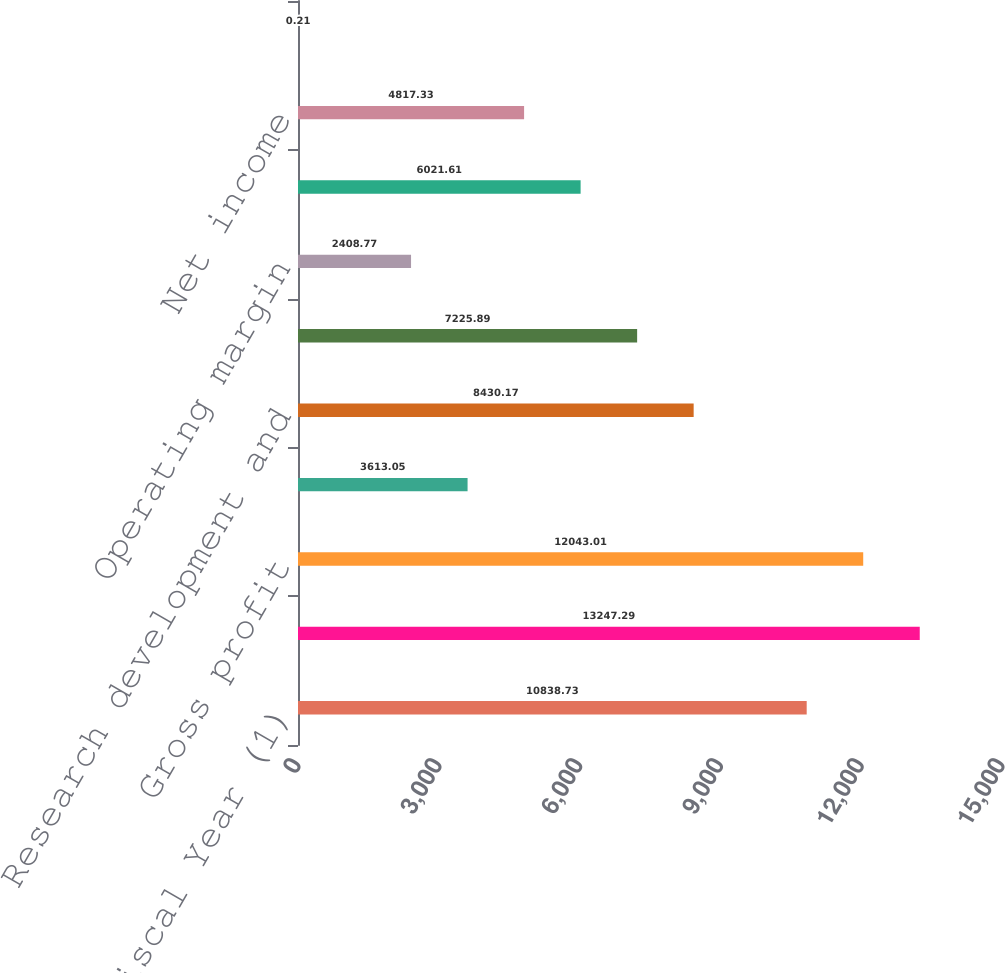Convert chart to OTSL. <chart><loc_0><loc_0><loc_500><loc_500><bar_chart><fcel>Fiscal Year (1)<fcel>Net sales<fcel>Gross profit<fcel>Gross margin<fcel>Research development and<fcel>Operating income<fcel>Operating margin<fcel>Income before income taxes<fcel>Net income<fcel>Earnings per diluted share<nl><fcel>10838.7<fcel>13247.3<fcel>12043<fcel>3613.05<fcel>8430.17<fcel>7225.89<fcel>2408.77<fcel>6021.61<fcel>4817.33<fcel>0.21<nl></chart> 